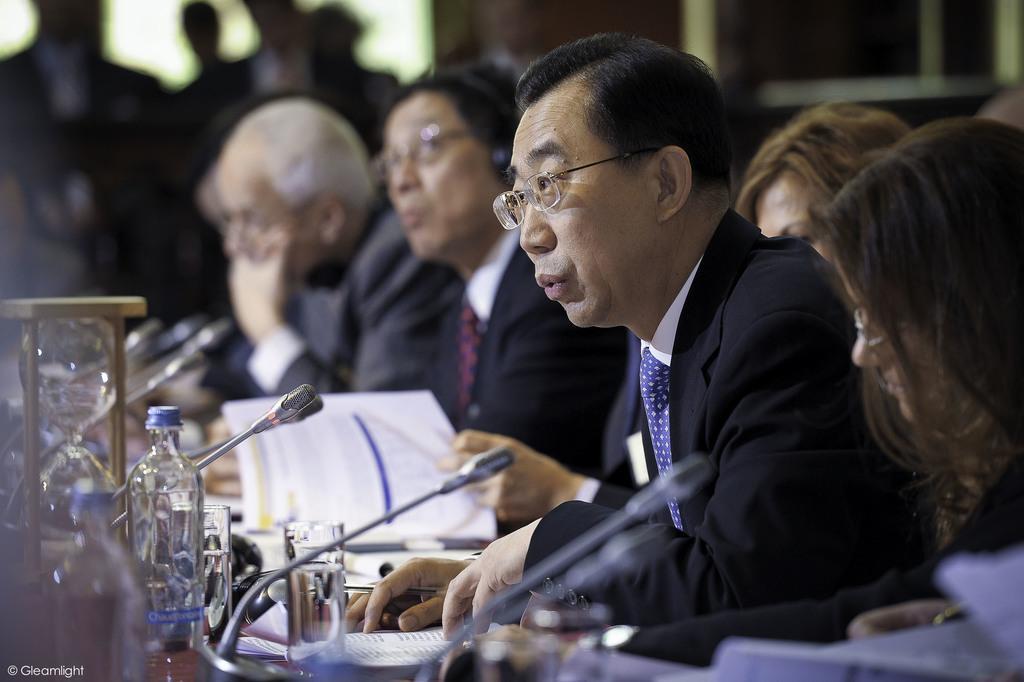Can you describe this image briefly? In this picture there are people those who are sitting in series in the center of the image and there is a table in front of them on which there are bottles, glasses, books, and mics on it, there are other people those who are standing in the background area of the image. 